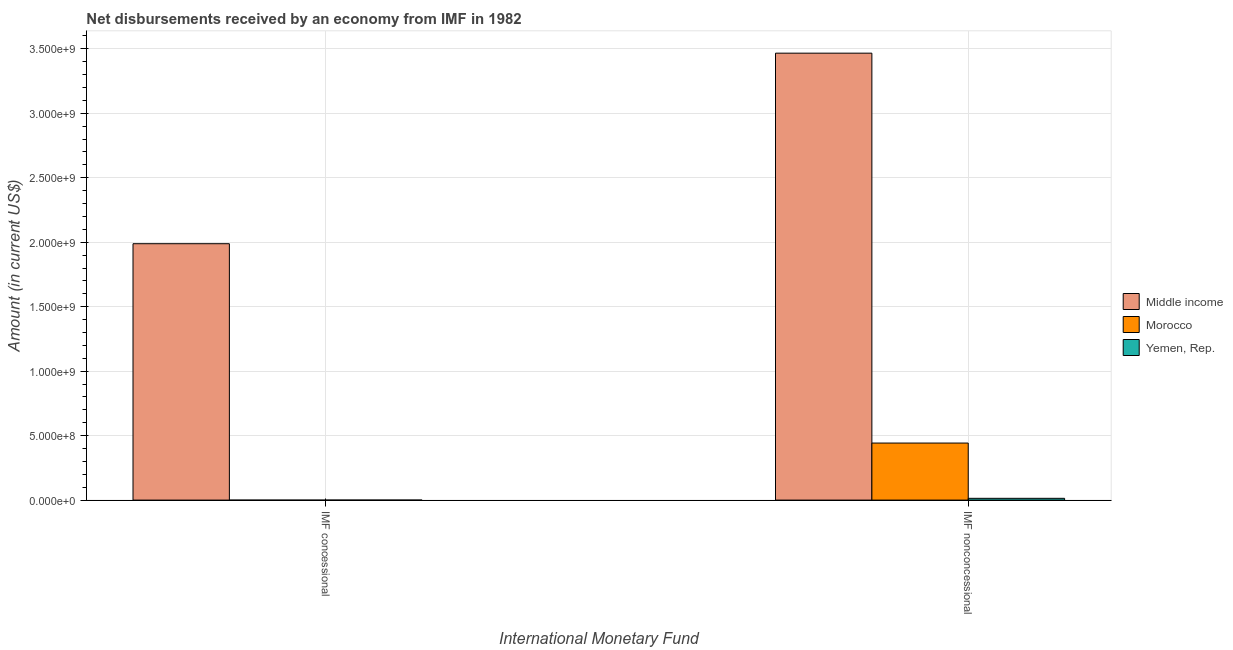How many different coloured bars are there?
Offer a terse response. 3. Are the number of bars per tick equal to the number of legend labels?
Ensure brevity in your answer.  No. Are the number of bars on each tick of the X-axis equal?
Provide a succinct answer. No. How many bars are there on the 2nd tick from the right?
Your answer should be very brief. 1. What is the label of the 2nd group of bars from the left?
Make the answer very short. IMF nonconcessional. Across all countries, what is the maximum net non concessional disbursements from imf?
Make the answer very short. 3.47e+09. Across all countries, what is the minimum net concessional disbursements from imf?
Keep it short and to the point. 0. In which country was the net concessional disbursements from imf maximum?
Provide a short and direct response. Middle income. What is the total net non concessional disbursements from imf in the graph?
Ensure brevity in your answer.  3.92e+09. What is the difference between the net non concessional disbursements from imf in Morocco and that in Middle income?
Your response must be concise. -3.02e+09. What is the difference between the net non concessional disbursements from imf in Morocco and the net concessional disbursements from imf in Middle income?
Offer a terse response. -1.55e+09. What is the average net concessional disbursements from imf per country?
Keep it short and to the point. 6.63e+08. What is the difference between the net concessional disbursements from imf and net non concessional disbursements from imf in Middle income?
Offer a terse response. -1.48e+09. What is the ratio of the net non concessional disbursements from imf in Morocco to that in Yemen, Rep.?
Your response must be concise. 32.06. Is the net non concessional disbursements from imf in Yemen, Rep. less than that in Morocco?
Offer a very short reply. Yes. Are all the bars in the graph horizontal?
Keep it short and to the point. No. How many countries are there in the graph?
Your answer should be very brief. 3. What is the difference between two consecutive major ticks on the Y-axis?
Give a very brief answer. 5.00e+08. Does the graph contain any zero values?
Your response must be concise. Yes. Does the graph contain grids?
Ensure brevity in your answer.  Yes. What is the title of the graph?
Ensure brevity in your answer.  Net disbursements received by an economy from IMF in 1982. Does "Uruguay" appear as one of the legend labels in the graph?
Provide a short and direct response. No. What is the label or title of the X-axis?
Offer a terse response. International Monetary Fund. What is the Amount (in current US$) in Middle income in IMF concessional?
Provide a succinct answer. 1.99e+09. What is the Amount (in current US$) of Middle income in IMF nonconcessional?
Offer a terse response. 3.47e+09. What is the Amount (in current US$) of Morocco in IMF nonconcessional?
Your answer should be compact. 4.42e+08. What is the Amount (in current US$) of Yemen, Rep. in IMF nonconcessional?
Your answer should be very brief. 1.38e+07. Across all International Monetary Fund, what is the maximum Amount (in current US$) of Middle income?
Make the answer very short. 3.47e+09. Across all International Monetary Fund, what is the maximum Amount (in current US$) of Morocco?
Ensure brevity in your answer.  4.42e+08. Across all International Monetary Fund, what is the maximum Amount (in current US$) in Yemen, Rep.?
Offer a very short reply. 1.38e+07. Across all International Monetary Fund, what is the minimum Amount (in current US$) of Middle income?
Give a very brief answer. 1.99e+09. Across all International Monetary Fund, what is the minimum Amount (in current US$) in Morocco?
Your response must be concise. 0. Across all International Monetary Fund, what is the minimum Amount (in current US$) in Yemen, Rep.?
Your response must be concise. 0. What is the total Amount (in current US$) in Middle income in the graph?
Keep it short and to the point. 5.45e+09. What is the total Amount (in current US$) of Morocco in the graph?
Keep it short and to the point. 4.42e+08. What is the total Amount (in current US$) in Yemen, Rep. in the graph?
Provide a succinct answer. 1.38e+07. What is the difference between the Amount (in current US$) in Middle income in IMF concessional and that in IMF nonconcessional?
Provide a short and direct response. -1.48e+09. What is the difference between the Amount (in current US$) in Middle income in IMF concessional and the Amount (in current US$) in Morocco in IMF nonconcessional?
Your answer should be very brief. 1.55e+09. What is the difference between the Amount (in current US$) of Middle income in IMF concessional and the Amount (in current US$) of Yemen, Rep. in IMF nonconcessional?
Your answer should be very brief. 1.97e+09. What is the average Amount (in current US$) in Middle income per International Monetary Fund?
Make the answer very short. 2.73e+09. What is the average Amount (in current US$) in Morocco per International Monetary Fund?
Your response must be concise. 2.21e+08. What is the average Amount (in current US$) in Yemen, Rep. per International Monetary Fund?
Offer a very short reply. 6.90e+06. What is the difference between the Amount (in current US$) of Middle income and Amount (in current US$) of Morocco in IMF nonconcessional?
Provide a short and direct response. 3.02e+09. What is the difference between the Amount (in current US$) of Middle income and Amount (in current US$) of Yemen, Rep. in IMF nonconcessional?
Offer a terse response. 3.45e+09. What is the difference between the Amount (in current US$) of Morocco and Amount (in current US$) of Yemen, Rep. in IMF nonconcessional?
Provide a succinct answer. 4.29e+08. What is the ratio of the Amount (in current US$) of Middle income in IMF concessional to that in IMF nonconcessional?
Your answer should be very brief. 0.57. What is the difference between the highest and the second highest Amount (in current US$) of Middle income?
Make the answer very short. 1.48e+09. What is the difference between the highest and the lowest Amount (in current US$) in Middle income?
Your answer should be compact. 1.48e+09. What is the difference between the highest and the lowest Amount (in current US$) in Morocco?
Keep it short and to the point. 4.42e+08. What is the difference between the highest and the lowest Amount (in current US$) of Yemen, Rep.?
Give a very brief answer. 1.38e+07. 